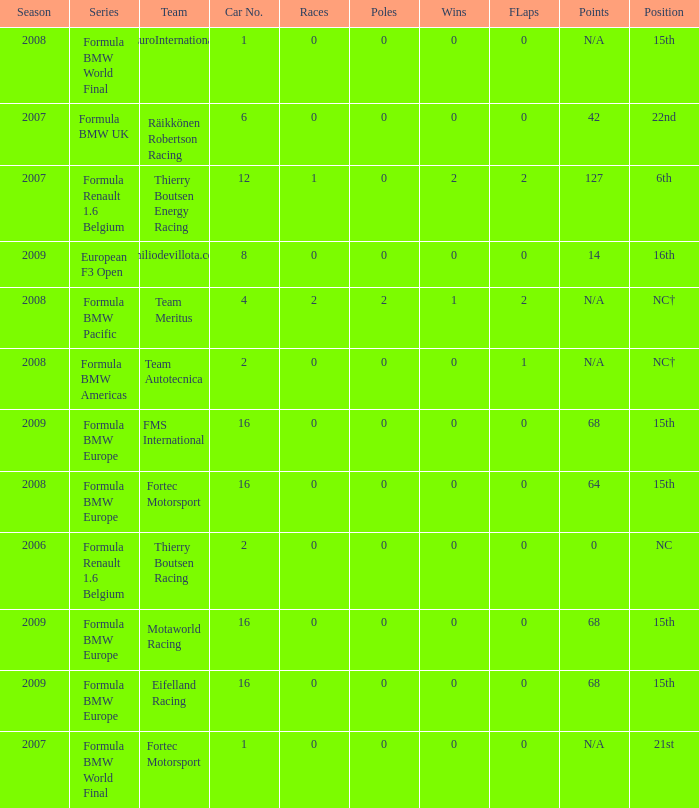Give me the full table as a dictionary. {'header': ['Season', 'Series', 'Team', 'Car No.', 'Races', 'Poles', 'Wins', 'FLaps', 'Points', 'Position'], 'rows': [['2008', 'Formula BMW World Final', 'EuroInternational', '1', '0', '0', '0', '0', 'N/A', '15th'], ['2007', 'Formula BMW UK', 'Räikkönen Robertson Racing', '6', '0', '0', '0', '0', '42', '22nd'], ['2007', 'Formula Renault 1.6 Belgium', 'Thierry Boutsen Energy Racing', '12', '1', '0', '2', '2', '127', '6th'], ['2009', 'European F3 Open', 'Emiliodevillota.com', '8', '0', '0', '0', '0', '14', '16th'], ['2008', 'Formula BMW Pacific', 'Team Meritus', '4', '2', '2', '1', '2', 'N/A', 'NC†'], ['2008', 'Formula BMW Americas', 'Team Autotecnica', '2', '0', '0', '0', '1', 'N/A', 'NC†'], ['2009', 'Formula BMW Europe', 'FMS International', '16', '0', '0', '0', '0', '68', '15th'], ['2008', 'Formula BMW Europe', 'Fortec Motorsport', '16', '0', '0', '0', '0', '64', '15th'], ['2006', 'Formula Renault 1.6 Belgium', 'Thierry Boutsen Racing', '2', '0', '0', '0', '0', '0', 'NC'], ['2009', 'Formula BMW Europe', 'Motaworld Racing', '16', '0', '0', '0', '0', '68', '15th'], ['2009', 'Formula BMW Europe', 'Eifelland Racing', '16', '0', '0', '0', '0', '68', '15th'], ['2007', 'Formula BMW World Final', 'Fortec Motorsport', '1', '0', '0', '0', '0', 'N/A', '21st']]} Name the most poles for 64 points 0.0. 